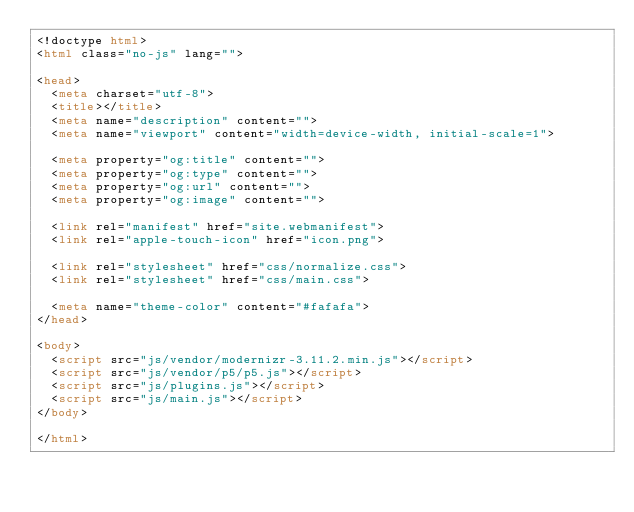Convert code to text. <code><loc_0><loc_0><loc_500><loc_500><_HTML_><!doctype html>
<html class="no-js" lang="">

<head>
  <meta charset="utf-8">
  <title></title>
  <meta name="description" content="">
  <meta name="viewport" content="width=device-width, initial-scale=1">

  <meta property="og:title" content="">
  <meta property="og:type" content="">
  <meta property="og:url" content="">
  <meta property="og:image" content="">

  <link rel="manifest" href="site.webmanifest">
  <link rel="apple-touch-icon" href="icon.png">

  <link rel="stylesheet" href="css/normalize.css">
  <link rel="stylesheet" href="css/main.css">

  <meta name="theme-color" content="#fafafa">
</head>

<body>
  <script src="js/vendor/modernizr-3.11.2.min.js"></script>
  <script src="js/vendor/p5/p5.js"></script>
  <script src="js/plugins.js"></script>
  <script src="js/main.js"></script>
</body>

</html>
</code> 